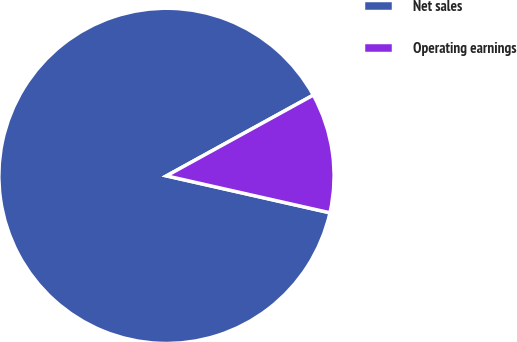Convert chart to OTSL. <chart><loc_0><loc_0><loc_500><loc_500><pie_chart><fcel>Net sales<fcel>Operating earnings<nl><fcel>88.46%<fcel>11.54%<nl></chart> 